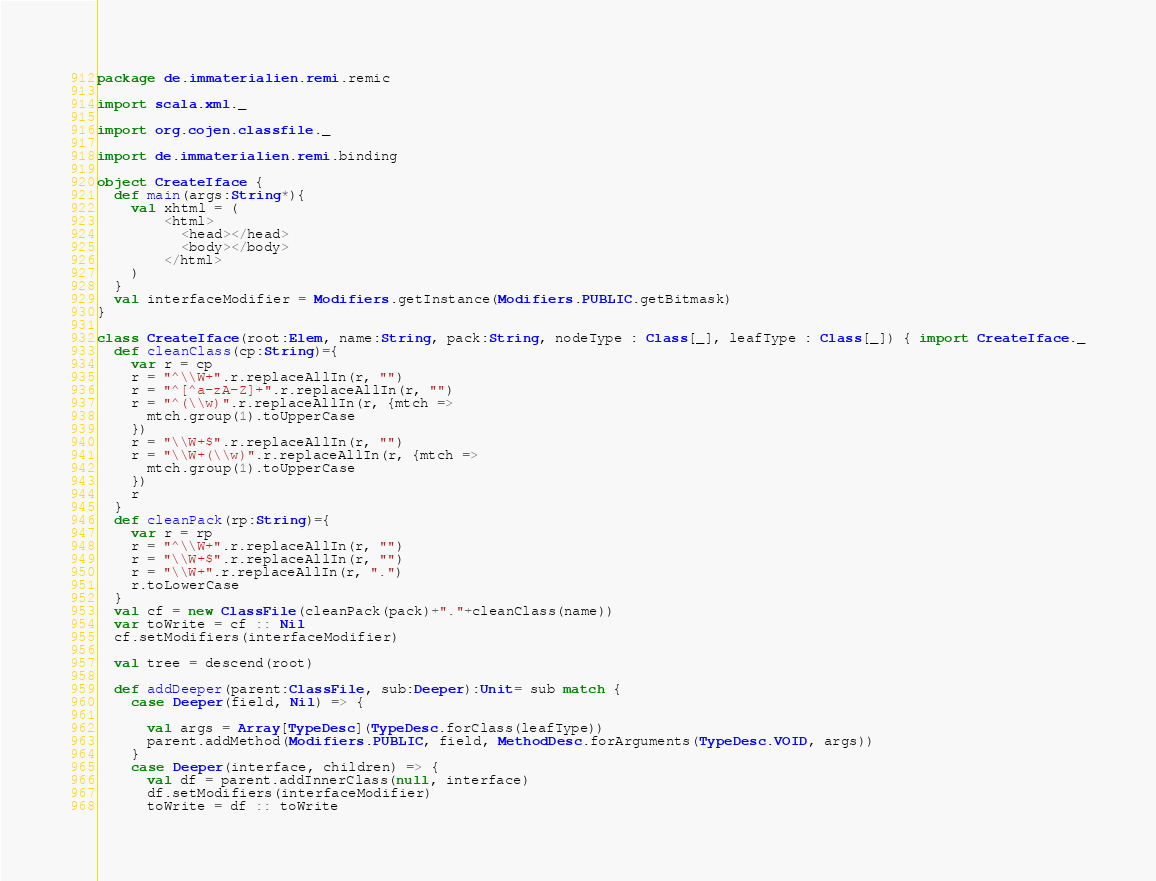Convert code to text. <code><loc_0><loc_0><loc_500><loc_500><_Scala_>package de.immaterialien.remi.remic

import scala.xml._

import org.cojen.classfile._

import de.immaterialien.remi.binding

object CreateIface {
  def main(args:String*){
    val xhtml = (
        <html>
          <head></head>
          <body></body>
        </html>
    )
  }
  val interfaceModifier = Modifiers.getInstance(Modifiers.PUBLIC.getBitmask)
}

class CreateIface(root:Elem, name:String, pack:String, nodeType : Class[_], leafType : Class[_]) { import CreateIface._
  def cleanClass(cp:String)={
    var r = cp
    r = "^\\W+".r.replaceAllIn(r, "")
    r = "^[^a-zA-Z]+".r.replaceAllIn(r, "")
    r = "^(\\w)".r.replaceAllIn(r, {mtch =>
      mtch.group(1).toUpperCase
    })
    r = "\\W+$".r.replaceAllIn(r, "")
    r = "\\W+(\\w)".r.replaceAllIn(r, {mtch =>
      mtch.group(1).toUpperCase
    })
    r
  }
  def cleanPack(rp:String)={ 
    var r = rp
    r = "^\\W+".r.replaceAllIn(r, "")
    r = "\\W+$".r.replaceAllIn(r, "")
    r = "\\W+".r.replaceAllIn(r, ".")
    r.toLowerCase
  }
  val cf = new ClassFile(cleanPack(pack)+"."+cleanClass(name))
  var toWrite = cf :: Nil
  cf.setModifiers(interfaceModifier)
  
  val tree = descend(root)

  def addDeeper(parent:ClassFile, sub:Deeper):Unit= sub match {
    case Deeper(field, Nil) => {

      val args = Array[TypeDesc](TypeDesc.forClass(leafType))
      parent.addMethod(Modifiers.PUBLIC, field, MethodDesc.forArguments(TypeDesc.VOID, args))
    }
    case Deeper(interface, children) => {
      val df = parent.addInnerClass(null, interface) 
      df.setModifiers(interfaceModifier)
      toWrite = df :: toWrite</code> 